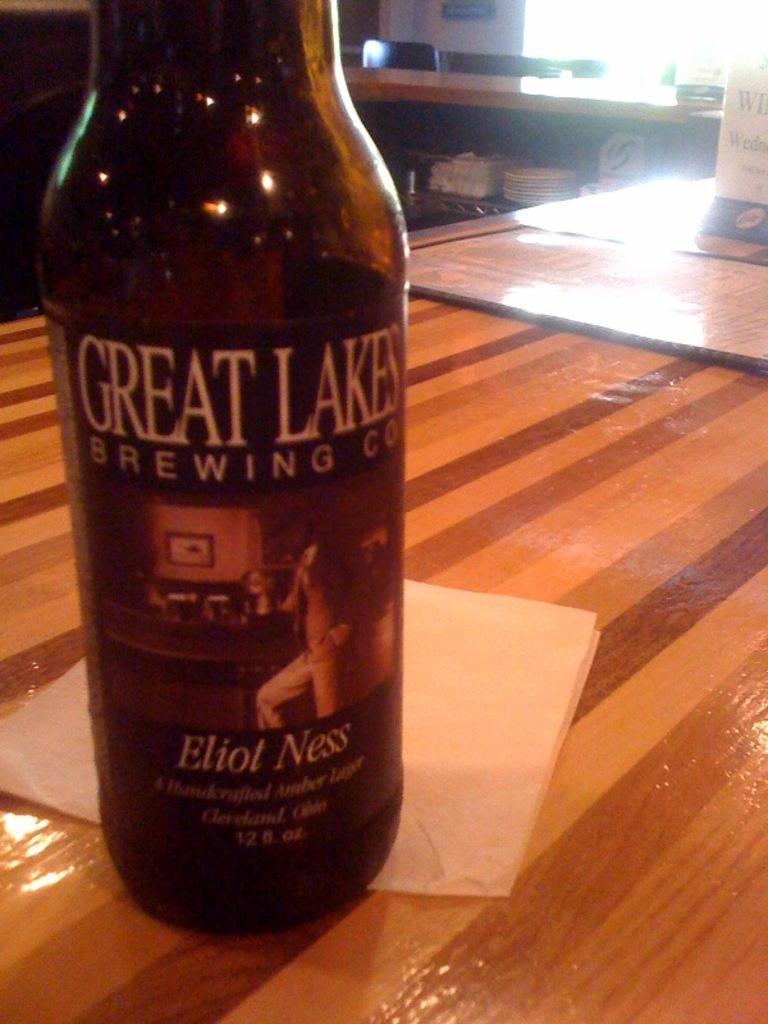<image>
Summarize the visual content of the image. A bottle of beer from Great Lakes Brewing says Eliot Ness on it. 